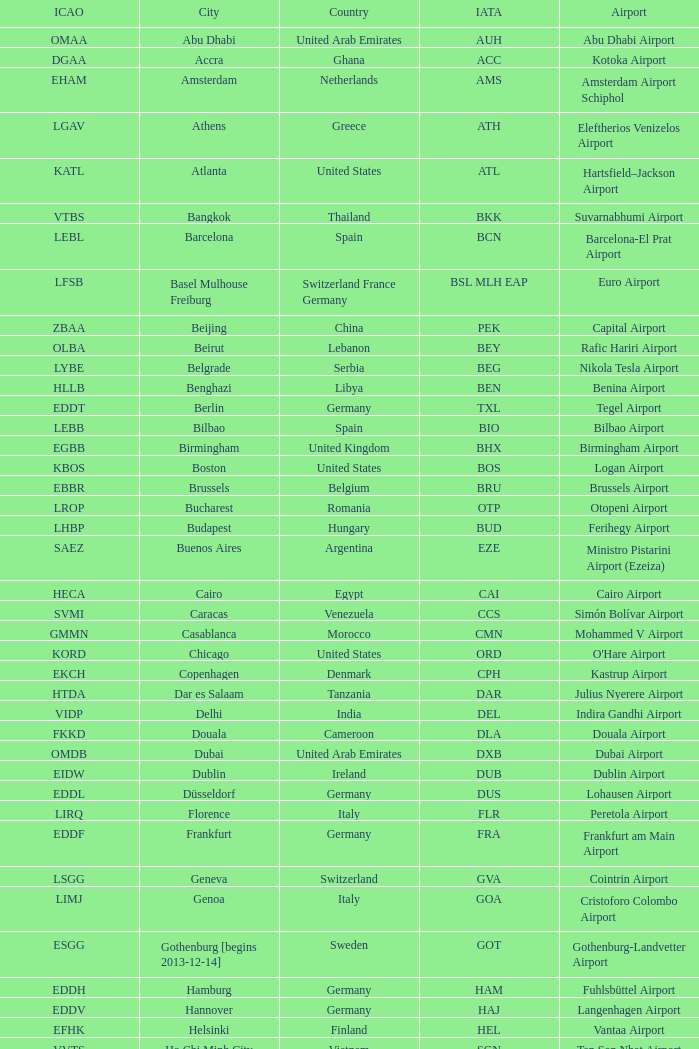Which city has the IATA SSG? Malabo. 